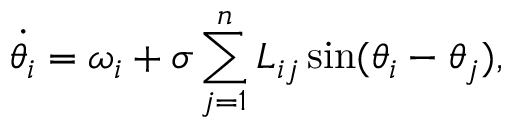Convert formula to latex. <formula><loc_0><loc_0><loc_500><loc_500>\ D o t { \theta _ { i } } = \omega _ { i } + \sigma \sum _ { j = 1 } ^ { n } L _ { i j } \sin ( \theta _ { i } - \theta _ { j } ) ,</formula> 